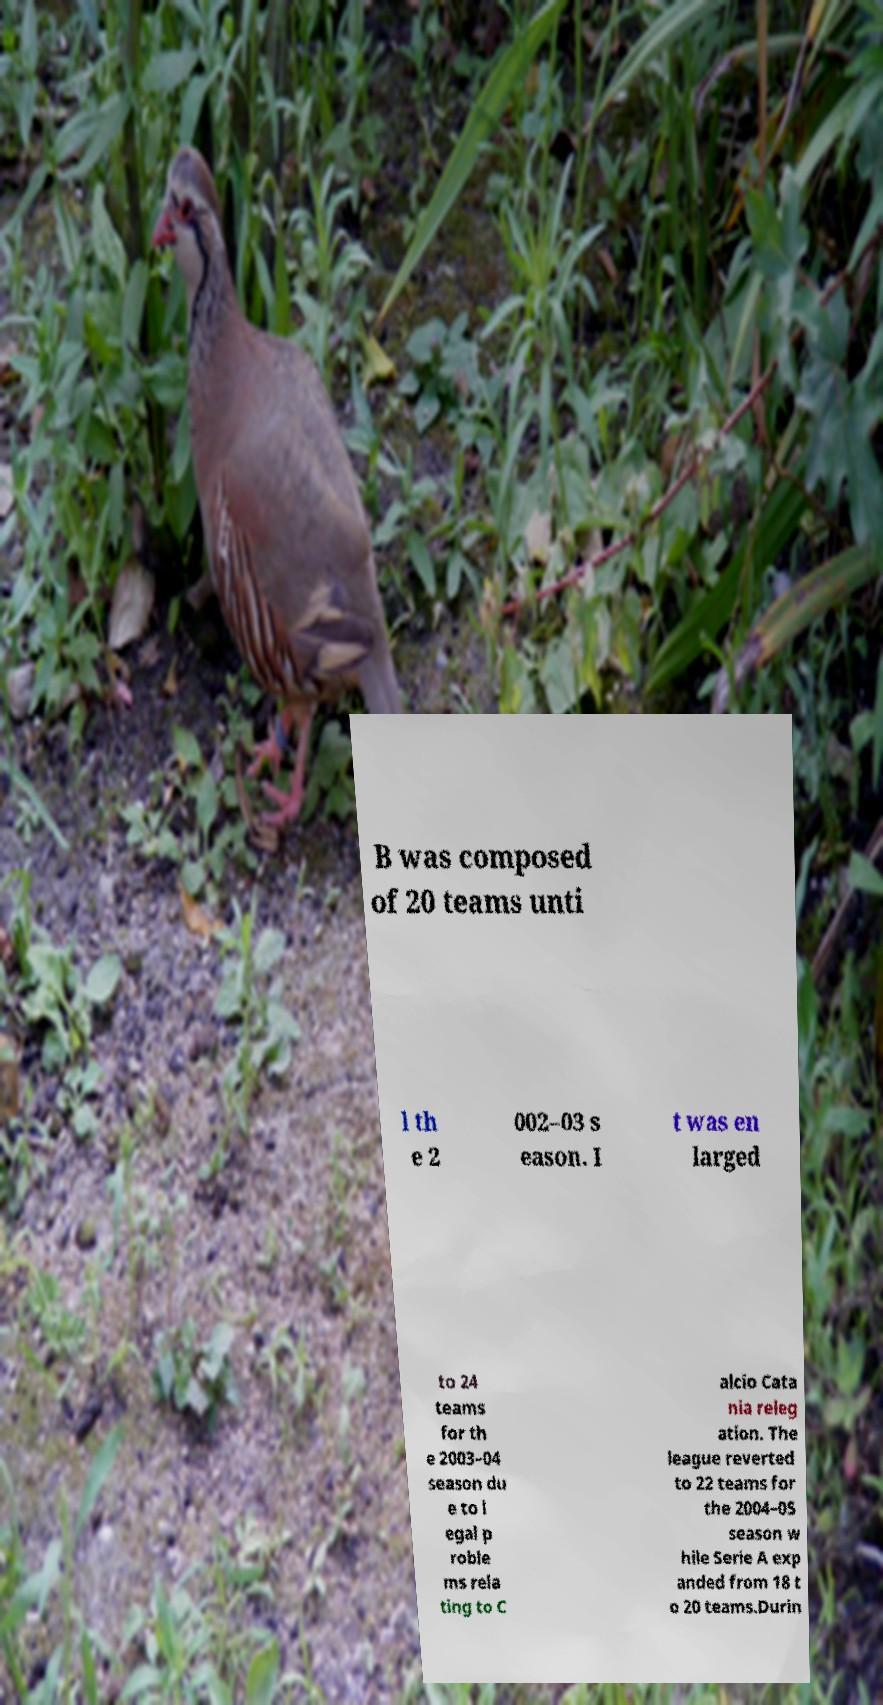I need the written content from this picture converted into text. Can you do that? B was composed of 20 teams unti l th e 2 002–03 s eason. I t was en larged to 24 teams for th e 2003–04 season du e to l egal p roble ms rela ting to C alcio Cata nia releg ation. The league reverted to 22 teams for the 2004–05 season w hile Serie A exp anded from 18 t o 20 teams.Durin 